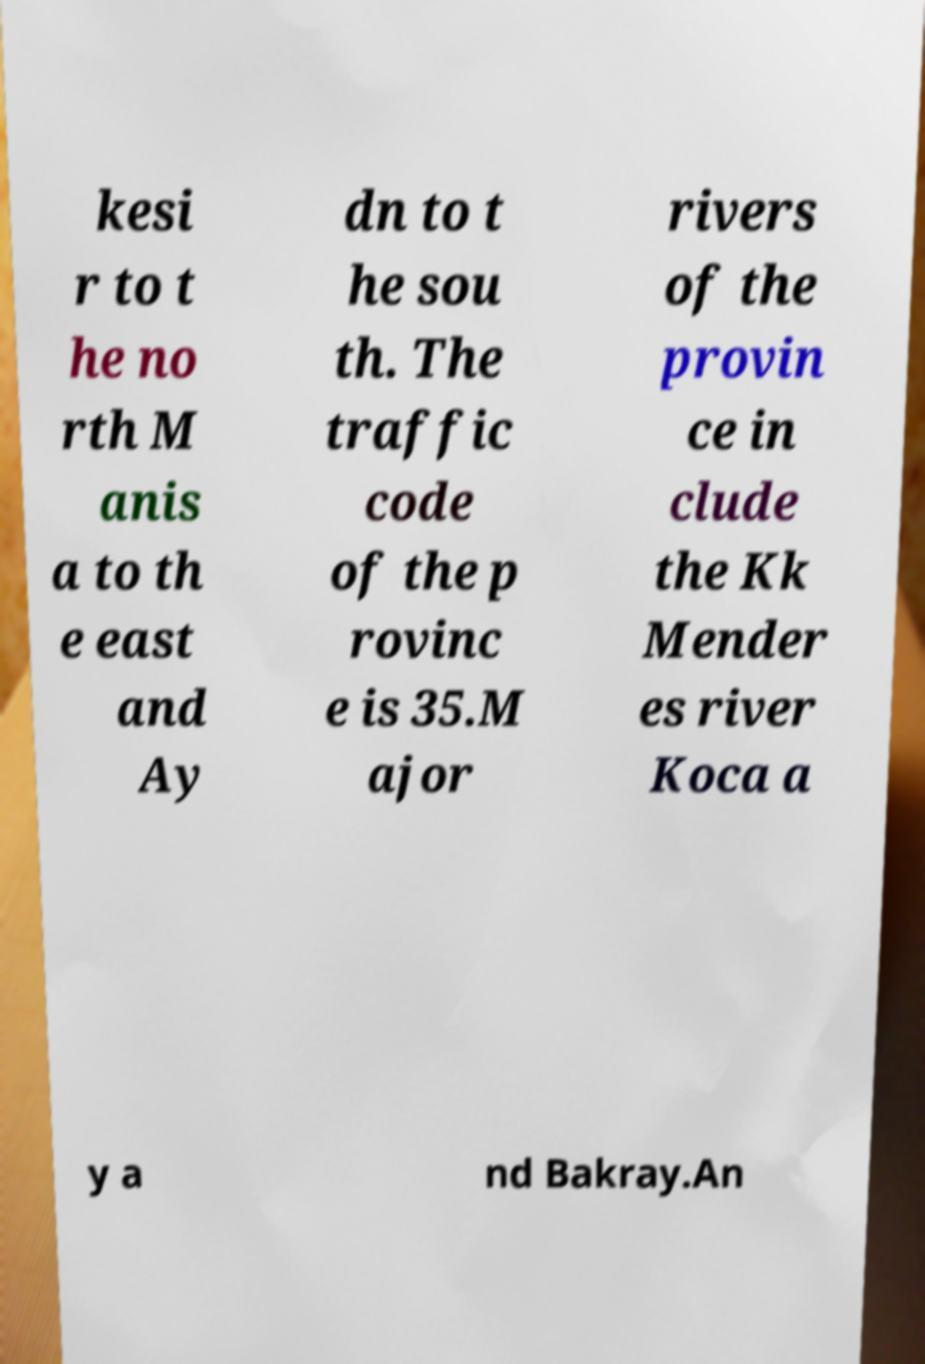Please read and relay the text visible in this image. What does it say? kesi r to t he no rth M anis a to th e east and Ay dn to t he sou th. The traffic code of the p rovinc e is 35.M ajor rivers of the provin ce in clude the Kk Mender es river Koca a y a nd Bakray.An 